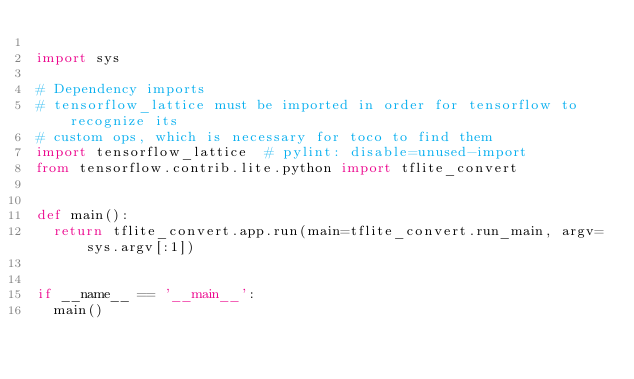<code> <loc_0><loc_0><loc_500><loc_500><_Python_>
import sys

# Dependency imports
# tensorflow_lattice must be imported in order for tensorflow to recognize its
# custom ops, which is necessary for toco to find them
import tensorflow_lattice  # pylint: disable=unused-import
from tensorflow.contrib.lite.python import tflite_convert


def main():
  return tflite_convert.app.run(main=tflite_convert.run_main, argv=sys.argv[:1])


if __name__ == '__main__':
  main()
</code> 